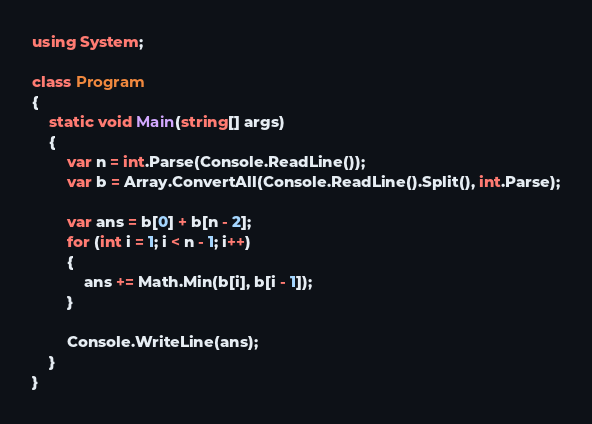<code> <loc_0><loc_0><loc_500><loc_500><_C#_>using System;

class Program
{
    static void Main(string[] args)
    {
        var n = int.Parse(Console.ReadLine());
        var b = Array.ConvertAll(Console.ReadLine().Split(), int.Parse);

        var ans = b[0] + b[n - 2];
        for (int i = 1; i < n - 1; i++)
        {
            ans += Math.Min(b[i], b[i - 1]);
        }

        Console.WriteLine(ans);
    }
}
</code> 